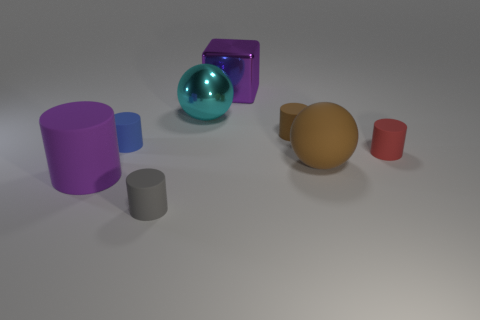Subtract 2 cylinders. How many cylinders are left? 3 Subtract all small red cylinders. How many cylinders are left? 4 Subtract all brown cylinders. How many cylinders are left? 4 Subtract all cyan cylinders. Subtract all gray balls. How many cylinders are left? 5 Add 1 large metallic cylinders. How many objects exist? 9 Subtract all blocks. How many objects are left? 7 Subtract all brown spheres. Subtract all brown things. How many objects are left? 5 Add 2 big rubber spheres. How many big rubber spheres are left? 3 Add 7 big purple shiny objects. How many big purple shiny objects exist? 8 Subtract 1 red cylinders. How many objects are left? 7 